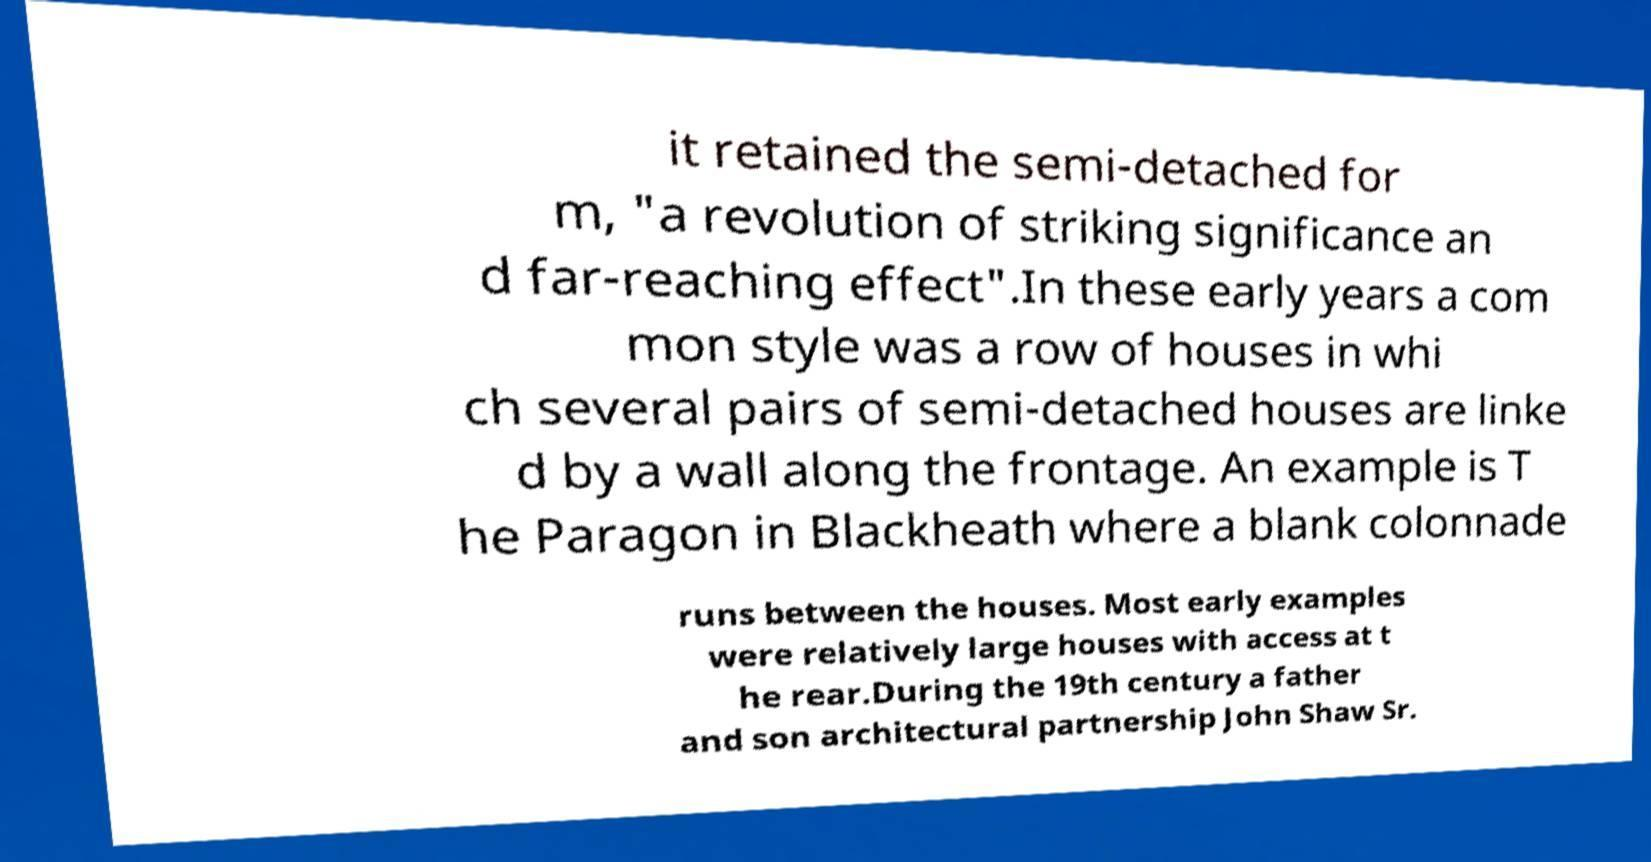Could you assist in decoding the text presented in this image and type it out clearly? it retained the semi-detached for m, "a revolution of striking significance an d far-reaching effect".In these early years a com mon style was a row of houses in whi ch several pairs of semi-detached houses are linke d by a wall along the frontage. An example is T he Paragon in Blackheath where a blank colonnade runs between the houses. Most early examples were relatively large houses with access at t he rear.During the 19th century a father and son architectural partnership John Shaw Sr. 